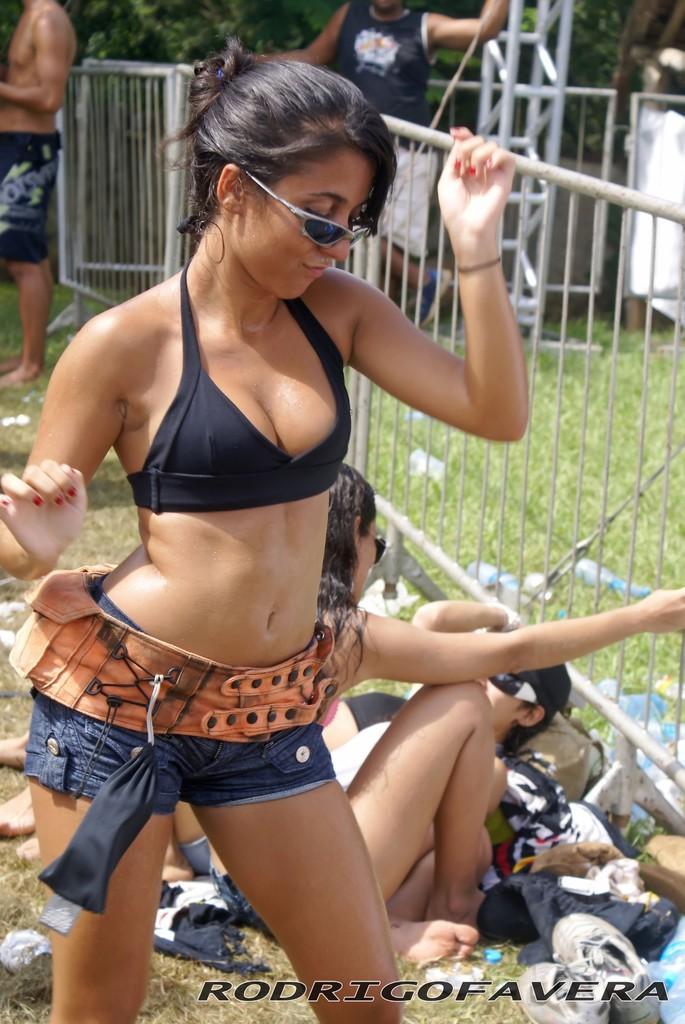Please provide a concise description of this image. This is an outside view. In this image I can see a few people are standing on the ground. Here I can see a woman ,it seems like she is dancing. At the back of her a person is lying on the ground and a person is sitting. On the right side, I can see a railing. There is grass on the ground. In the background, I can see the trees. 